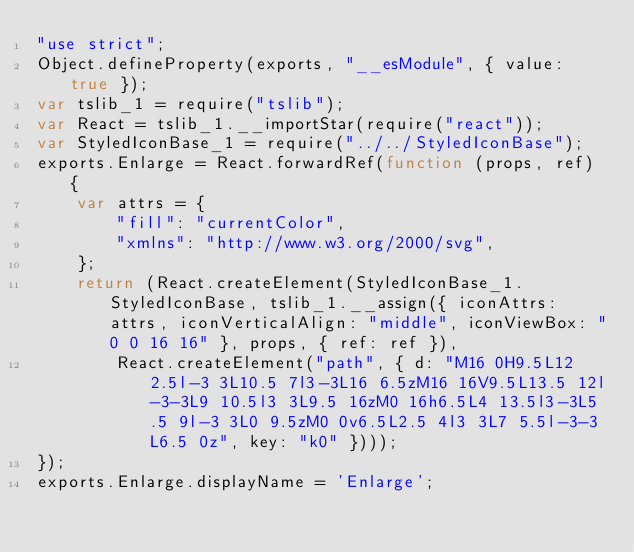<code> <loc_0><loc_0><loc_500><loc_500><_JavaScript_>"use strict";
Object.defineProperty(exports, "__esModule", { value: true });
var tslib_1 = require("tslib");
var React = tslib_1.__importStar(require("react"));
var StyledIconBase_1 = require("../../StyledIconBase");
exports.Enlarge = React.forwardRef(function (props, ref) {
    var attrs = {
        "fill": "currentColor",
        "xmlns": "http://www.w3.org/2000/svg",
    };
    return (React.createElement(StyledIconBase_1.StyledIconBase, tslib_1.__assign({ iconAttrs: attrs, iconVerticalAlign: "middle", iconViewBox: "0 0 16 16" }, props, { ref: ref }),
        React.createElement("path", { d: "M16 0H9.5L12 2.5l-3 3L10.5 7l3-3L16 6.5zM16 16V9.5L13.5 12l-3-3L9 10.5l3 3L9.5 16zM0 16h6.5L4 13.5l3-3L5.5 9l-3 3L0 9.5zM0 0v6.5L2.5 4l3 3L7 5.5l-3-3L6.5 0z", key: "k0" })));
});
exports.Enlarge.displayName = 'Enlarge';</code> 